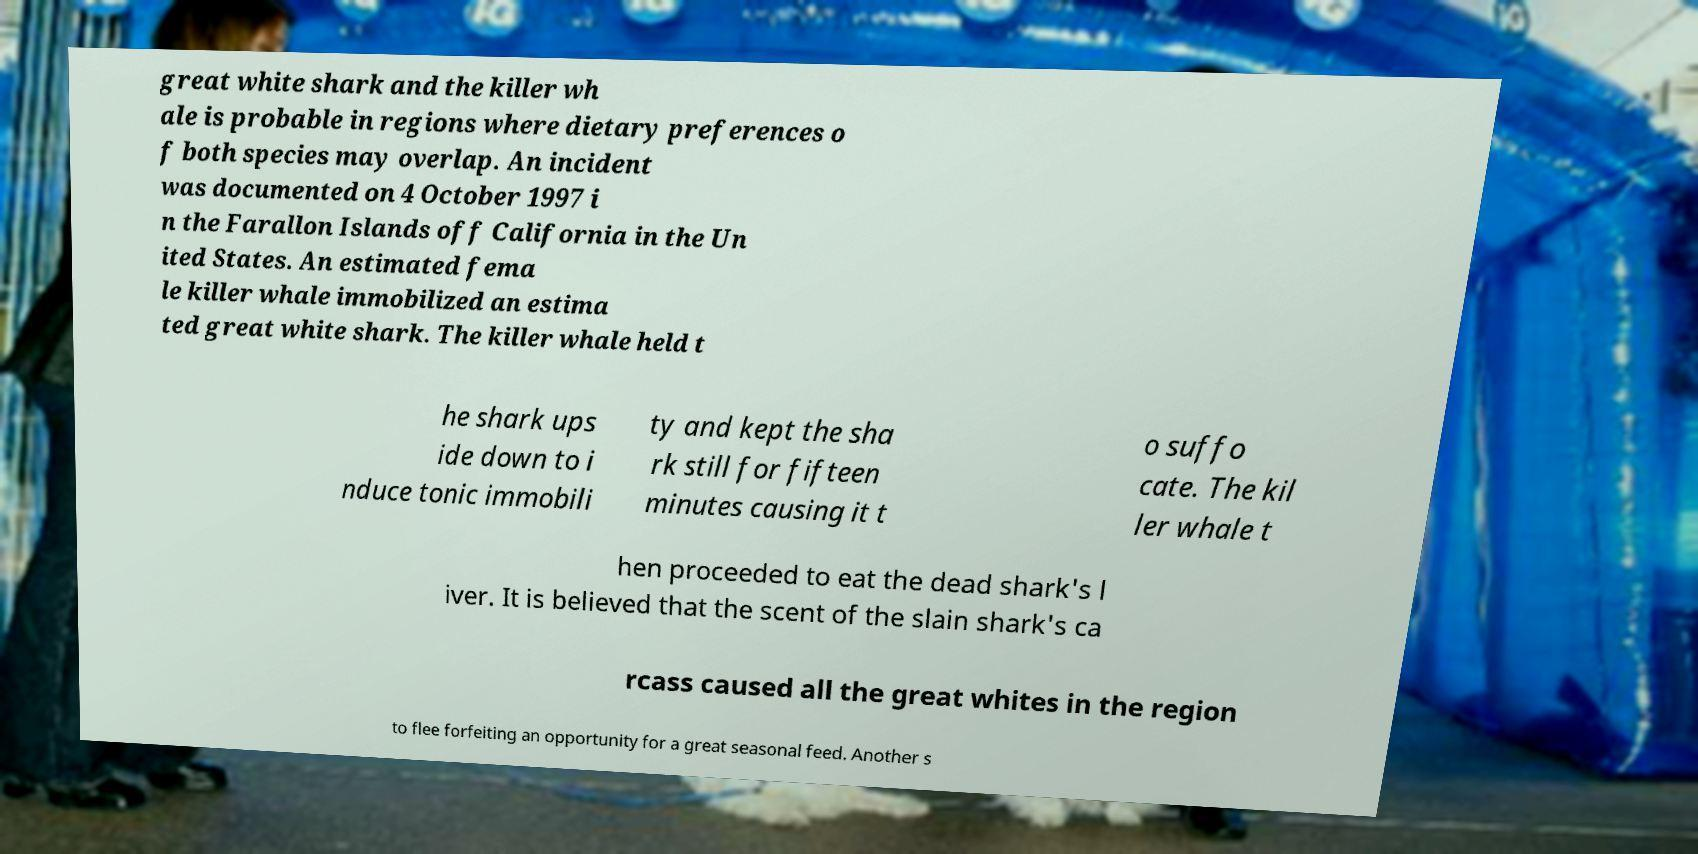Please identify and transcribe the text found in this image. great white shark and the killer wh ale is probable in regions where dietary preferences o f both species may overlap. An incident was documented on 4 October 1997 i n the Farallon Islands off California in the Un ited States. An estimated fema le killer whale immobilized an estima ted great white shark. The killer whale held t he shark ups ide down to i nduce tonic immobili ty and kept the sha rk still for fifteen minutes causing it t o suffo cate. The kil ler whale t hen proceeded to eat the dead shark's l iver. It is believed that the scent of the slain shark's ca rcass caused all the great whites in the region to flee forfeiting an opportunity for a great seasonal feed. Another s 